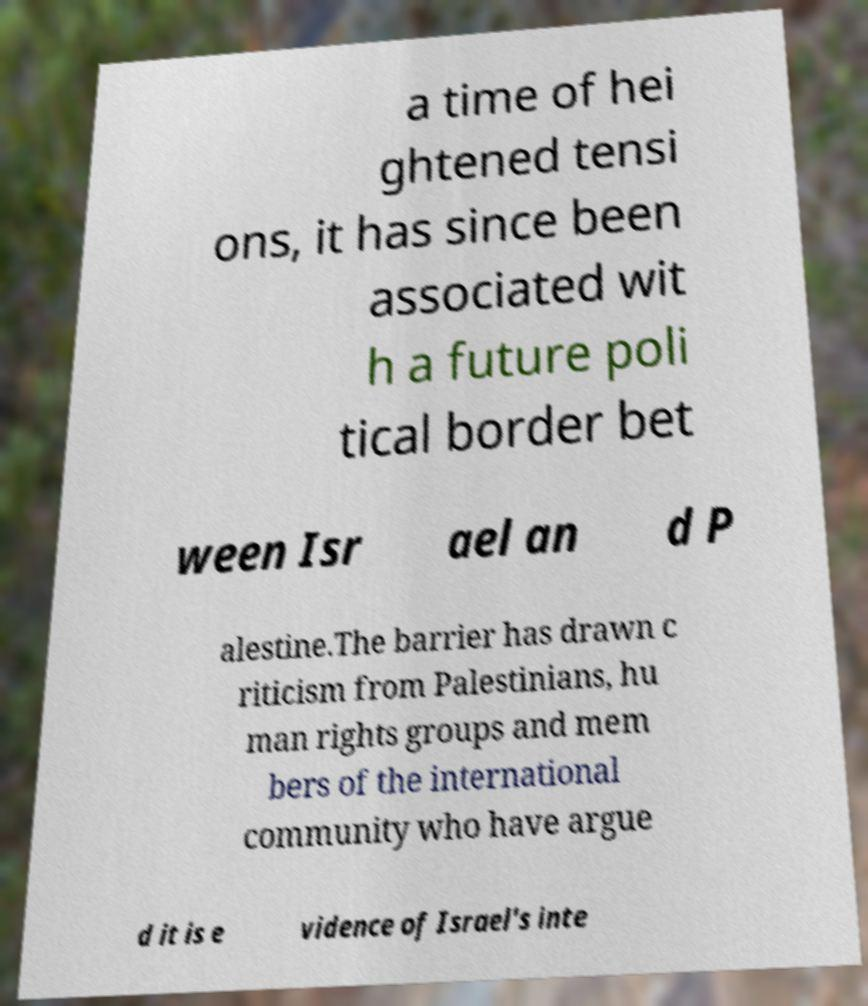Could you assist in decoding the text presented in this image and type it out clearly? a time of hei ghtened tensi ons, it has since been associated wit h a future poli tical border bet ween Isr ael an d P alestine.The barrier has drawn c riticism from Palestinians, hu man rights groups and mem bers of the international community who have argue d it is e vidence of Israel's inte 